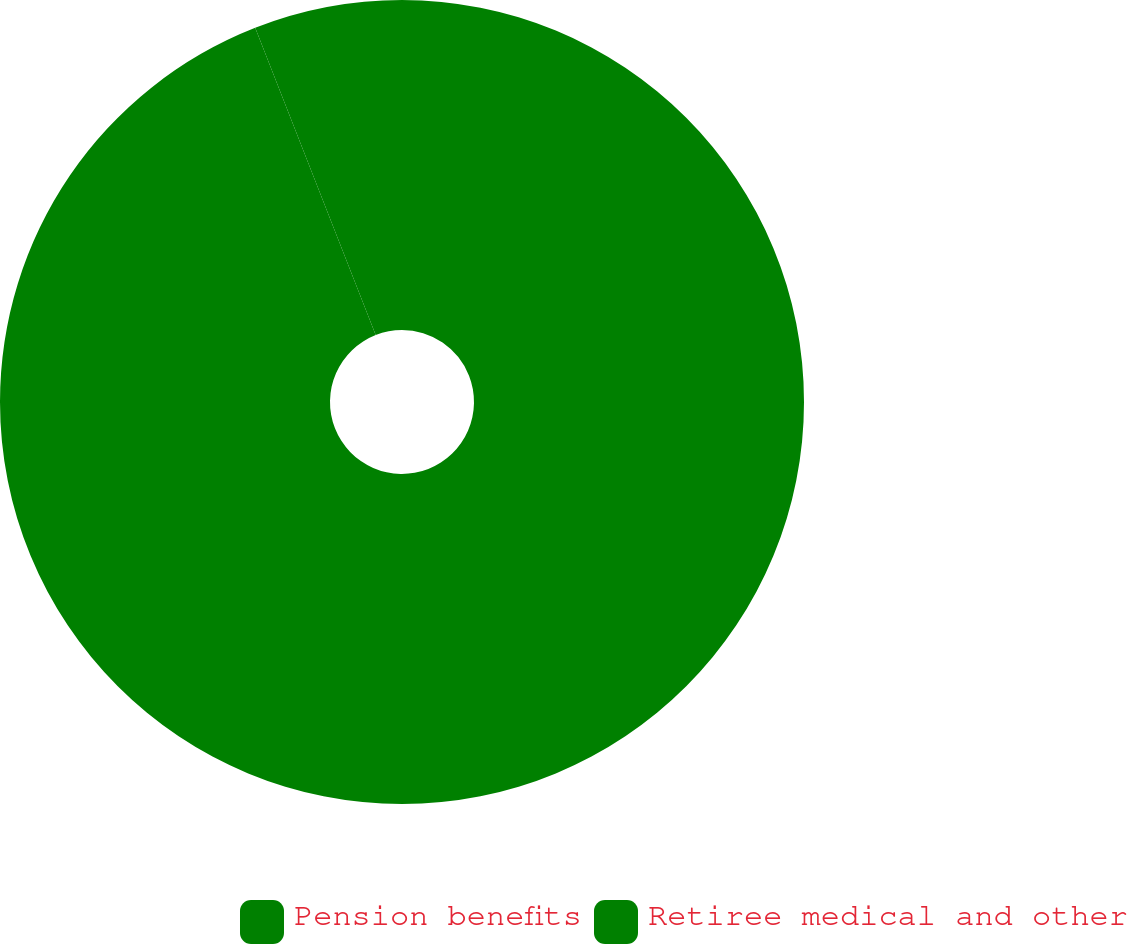<chart> <loc_0><loc_0><loc_500><loc_500><pie_chart><fcel>Pension benefits<fcel>Retiree medical and other<nl><fcel>94.05%<fcel>5.95%<nl></chart> 